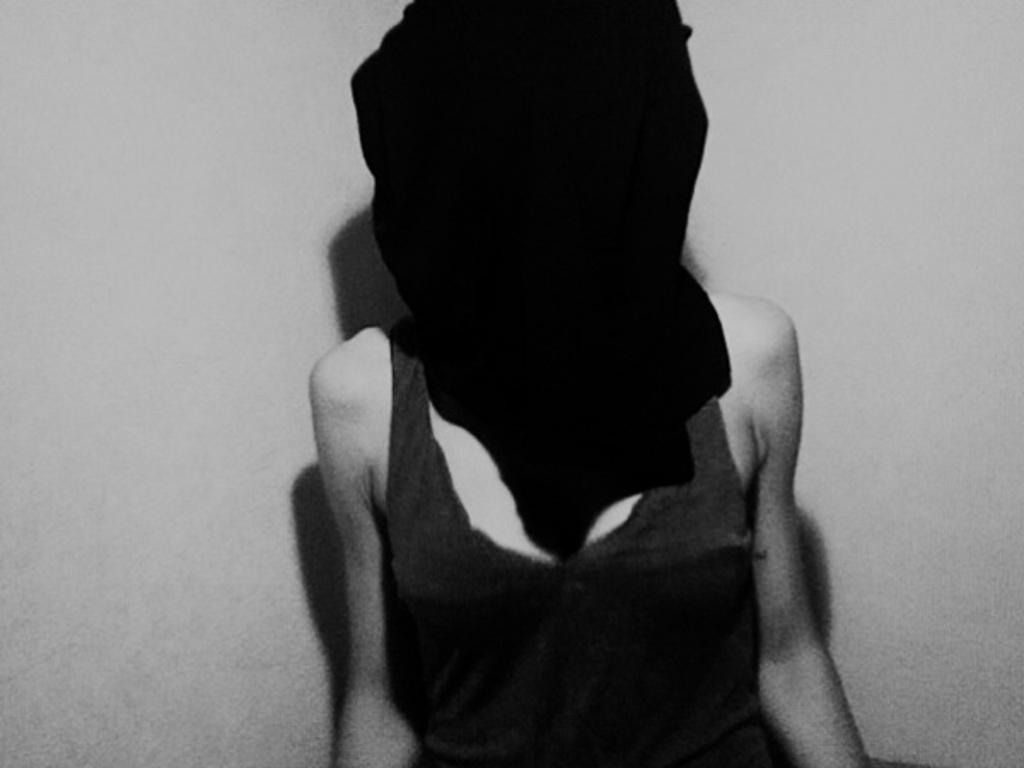Who is the main subject in the image? There is a woman in the middle of the image. What is the woman wearing on her face? The woman is wearing a black color mask on her face. What can be seen in the background of the image? There is a wall in the background of the image. What type of chairs can be seen in the image? There are no chairs present in the image. What activity is the woman engaged in while wearing the mask? The image does not provide information about the activity the woman is engaged in. 